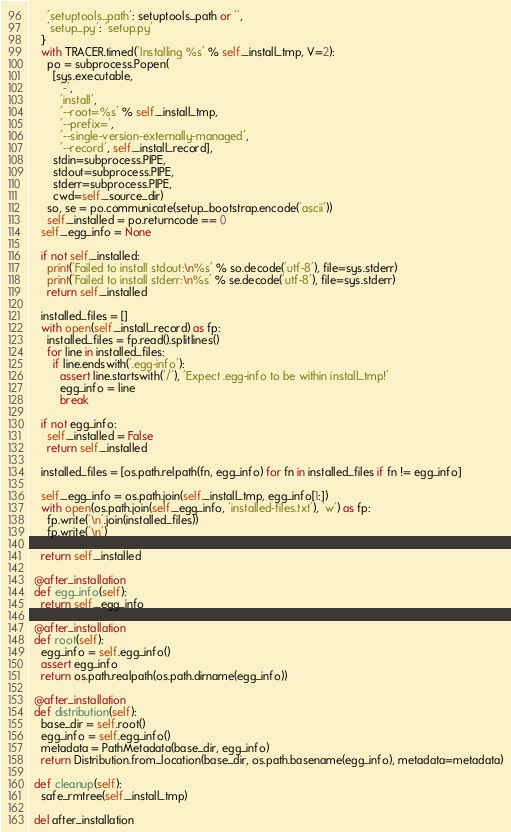Convert code to text. <code><loc_0><loc_0><loc_500><loc_500><_Python_>      'setuptools_path': setuptools_path or '',
      'setup_py': 'setup.py'
    }
    with TRACER.timed('Installing %s' % self._install_tmp, V=2):
      po = subprocess.Popen(
        [sys.executable,
          '-',
          'install',
          '--root=%s' % self._install_tmp,
          '--prefix=',
          '--single-version-externally-managed',
          '--record', self._install_record],
        stdin=subprocess.PIPE,
        stdout=subprocess.PIPE,
        stderr=subprocess.PIPE,
        cwd=self._source_dir)
      so, se = po.communicate(setup_bootstrap.encode('ascii'))
      self._installed = po.returncode == 0
    self._egg_info = None

    if not self._installed:
      print('Failed to install stdout:\n%s' % so.decode('utf-8'), file=sys.stderr)
      print('Failed to install stderr:\n%s' % se.decode('utf-8'), file=sys.stderr)
      return self._installed

    installed_files = []
    with open(self._install_record) as fp:
      installed_files = fp.read().splitlines()
      for line in installed_files:
        if line.endswith('.egg-info'):
          assert line.startswith('/'), 'Expect .egg-info to be within install_tmp!'
          egg_info = line
          break

    if not egg_info:
      self._installed = False
      return self._installed

    installed_files = [os.path.relpath(fn, egg_info) for fn in installed_files if fn != egg_info]

    self._egg_info = os.path.join(self._install_tmp, egg_info[1:])
    with open(os.path.join(self._egg_info, 'installed-files.txt'), 'w') as fp:
      fp.write('\n'.join(installed_files))
      fp.write('\n')

    return self._installed

  @after_installation
  def egg_info(self):
    return self._egg_info

  @after_installation
  def root(self):
    egg_info = self.egg_info()
    assert egg_info
    return os.path.realpath(os.path.dirname(egg_info))

  @after_installation
  def distribution(self):
    base_dir = self.root()
    egg_info = self.egg_info()
    metadata = PathMetadata(base_dir, egg_info)
    return Distribution.from_location(base_dir, os.path.basename(egg_info), metadata=metadata)

  def cleanup(self):
    safe_rmtree(self._install_tmp)

  del after_installation
</code> 